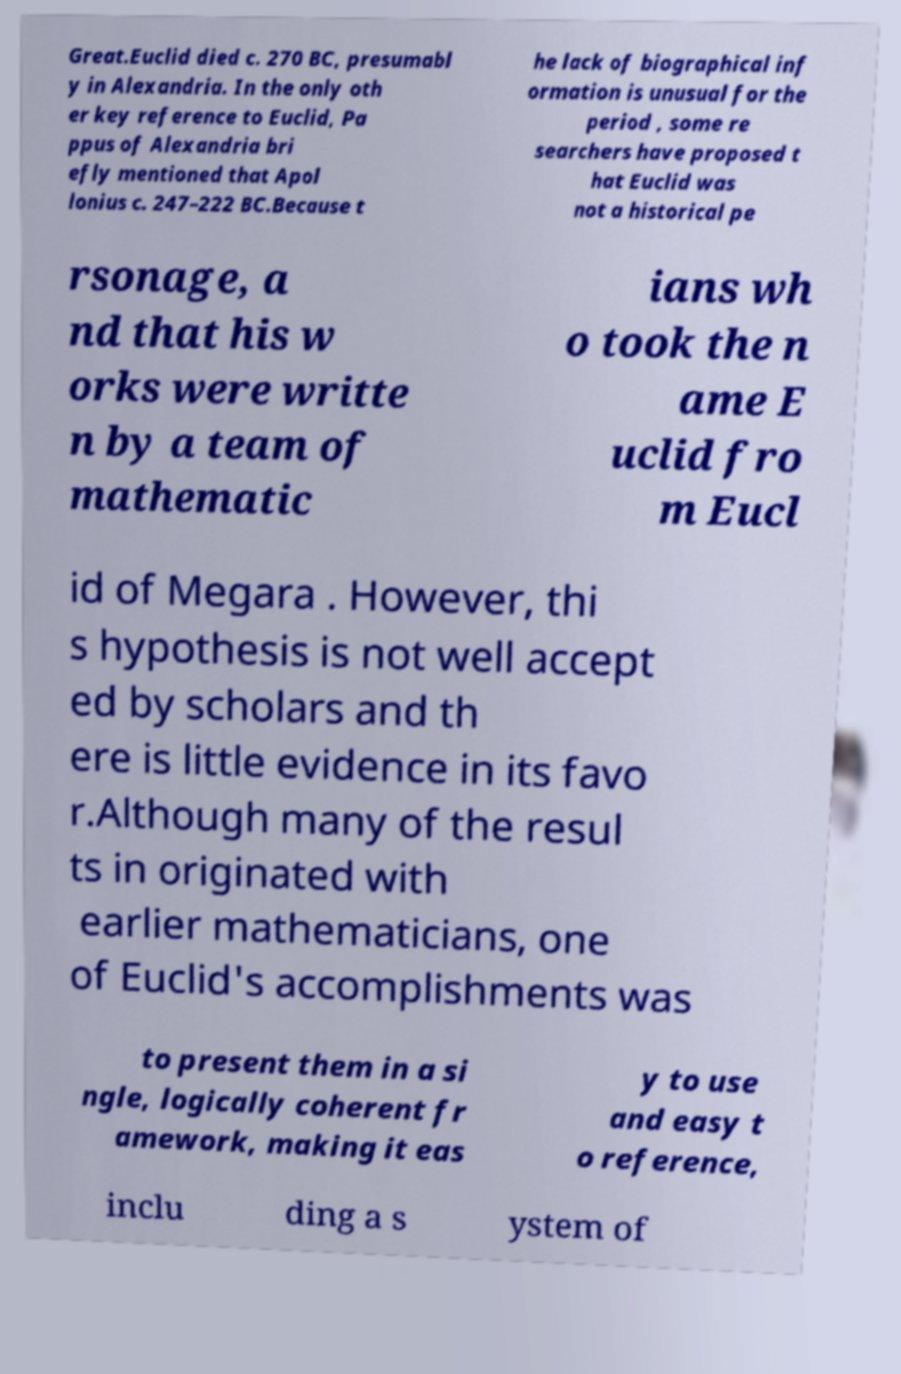What messages or text are displayed in this image? I need them in a readable, typed format. Great.Euclid died c. 270 BC, presumabl y in Alexandria. In the only oth er key reference to Euclid, Pa ppus of Alexandria bri efly mentioned that Apol lonius c. 247–222 BC.Because t he lack of biographical inf ormation is unusual for the period , some re searchers have proposed t hat Euclid was not a historical pe rsonage, a nd that his w orks were writte n by a team of mathematic ians wh o took the n ame E uclid fro m Eucl id of Megara . However, thi s hypothesis is not well accept ed by scholars and th ere is little evidence in its favo r.Although many of the resul ts in originated with earlier mathematicians, one of Euclid's accomplishments was to present them in a si ngle, logically coherent fr amework, making it eas y to use and easy t o reference, inclu ding a s ystem of 